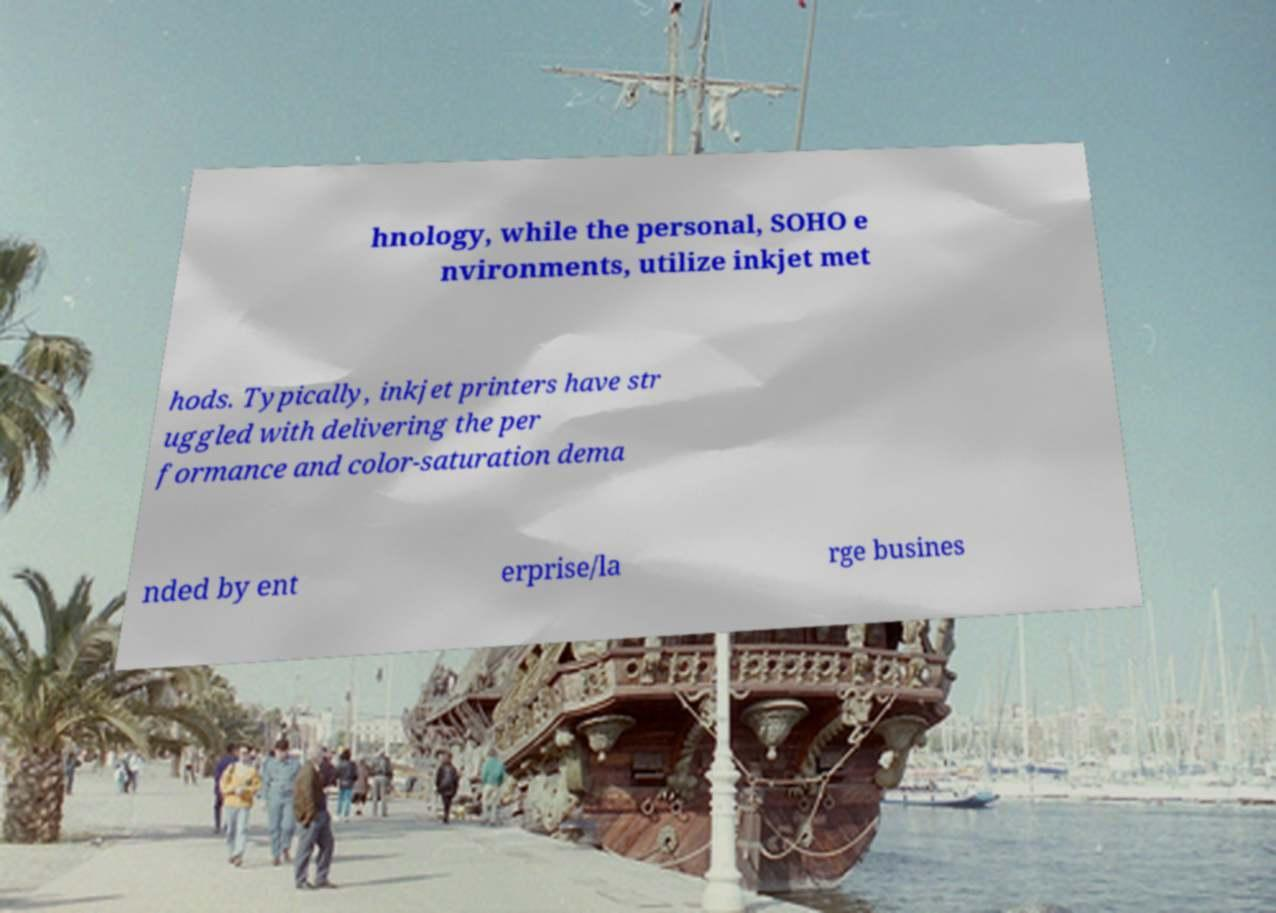Can you accurately transcribe the text from the provided image for me? hnology, while the personal, SOHO e nvironments, utilize inkjet met hods. Typically, inkjet printers have str uggled with delivering the per formance and color-saturation dema nded by ent erprise/la rge busines 